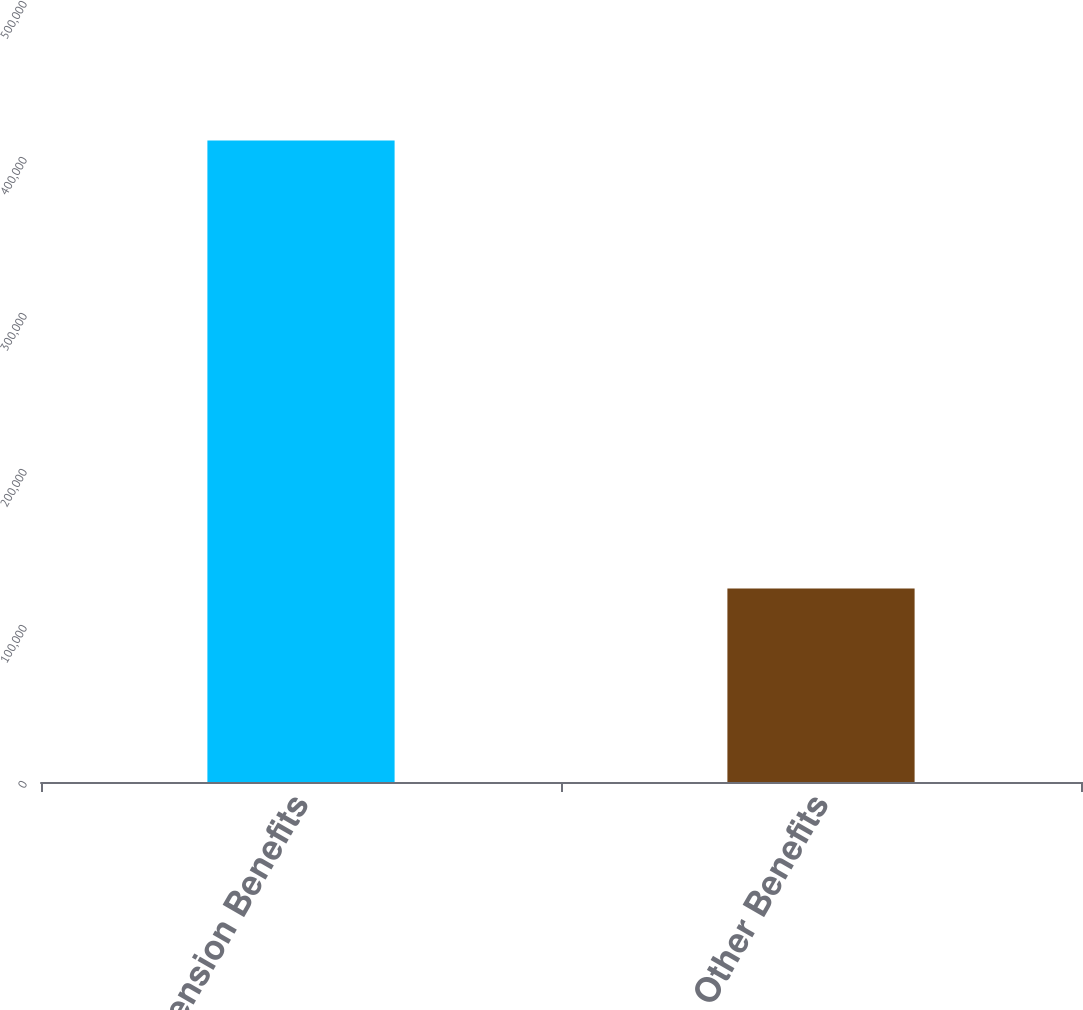Convert chart. <chart><loc_0><loc_0><loc_500><loc_500><bar_chart><fcel>Pension Benefits<fcel>Other Benefits<nl><fcel>411204<fcel>123996<nl></chart> 